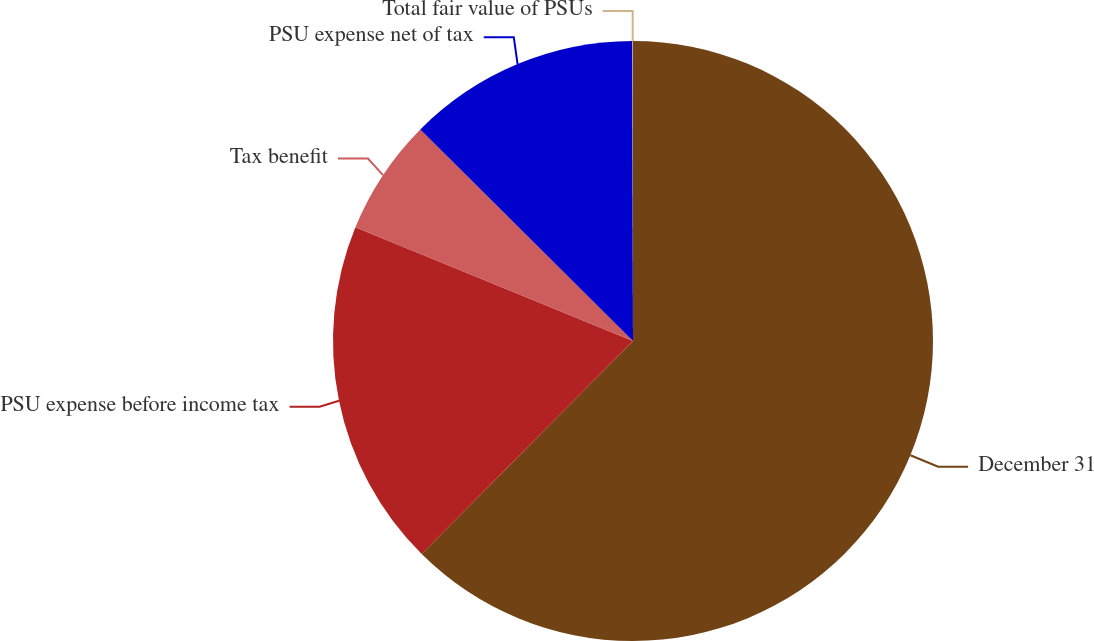Convert chart to OTSL. <chart><loc_0><loc_0><loc_500><loc_500><pie_chart><fcel>December 31<fcel>PSU expense before income tax<fcel>Tax benefit<fcel>PSU expense net of tax<fcel>Total fair value of PSUs<nl><fcel>62.43%<fcel>18.75%<fcel>6.27%<fcel>12.51%<fcel>0.03%<nl></chart> 